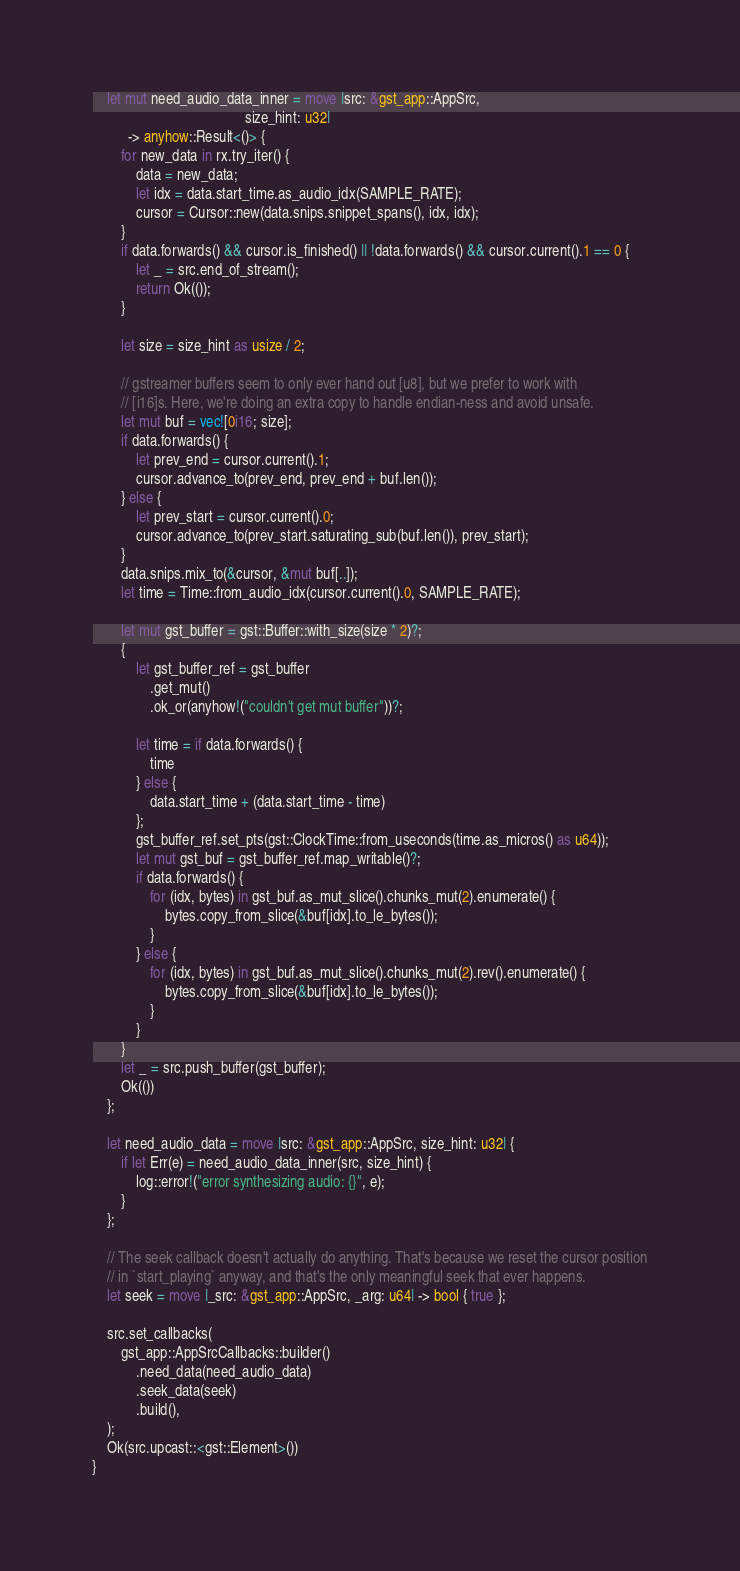<code> <loc_0><loc_0><loc_500><loc_500><_Rust_>    let mut need_audio_data_inner = move |src: &gst_app::AppSrc,
                                          size_hint: u32|
          -> anyhow::Result<()> {
        for new_data in rx.try_iter() {
            data = new_data;
            let idx = data.start_time.as_audio_idx(SAMPLE_RATE);
            cursor = Cursor::new(data.snips.snippet_spans(), idx, idx);
        }
        if data.forwards() && cursor.is_finished() || !data.forwards() && cursor.current().1 == 0 {
            let _ = src.end_of_stream();
            return Ok(());
        }

        let size = size_hint as usize / 2;

        // gstreamer buffers seem to only ever hand out [u8], but we prefer to work with
        // [i16]s. Here, we're doing an extra copy to handle endian-ness and avoid unsafe.
        let mut buf = vec![0i16; size];
        if data.forwards() {
            let prev_end = cursor.current().1;
            cursor.advance_to(prev_end, prev_end + buf.len());
        } else {
            let prev_start = cursor.current().0;
            cursor.advance_to(prev_start.saturating_sub(buf.len()), prev_start);
        }
        data.snips.mix_to(&cursor, &mut buf[..]);
        let time = Time::from_audio_idx(cursor.current().0, SAMPLE_RATE);

        let mut gst_buffer = gst::Buffer::with_size(size * 2)?;
        {
            let gst_buffer_ref = gst_buffer
                .get_mut()
                .ok_or(anyhow!("couldn't get mut buffer"))?;

            let time = if data.forwards() {
                time
            } else {
                data.start_time + (data.start_time - time)
            };
            gst_buffer_ref.set_pts(gst::ClockTime::from_useconds(time.as_micros() as u64));
            let mut gst_buf = gst_buffer_ref.map_writable()?;
            if data.forwards() {
                for (idx, bytes) in gst_buf.as_mut_slice().chunks_mut(2).enumerate() {
                    bytes.copy_from_slice(&buf[idx].to_le_bytes());
                }
            } else {
                for (idx, bytes) in gst_buf.as_mut_slice().chunks_mut(2).rev().enumerate() {
                    bytes.copy_from_slice(&buf[idx].to_le_bytes());
                }
            }
        }
        let _ = src.push_buffer(gst_buffer);
        Ok(())
    };

    let need_audio_data = move |src: &gst_app::AppSrc, size_hint: u32| {
        if let Err(e) = need_audio_data_inner(src, size_hint) {
            log::error!("error synthesizing audio: {}", e);
        }
    };

    // The seek callback doesn't actually do anything. That's because we reset the cursor position
    // in `start_playing` anyway, and that's the only meaningful seek that ever happens.
    let seek = move |_src: &gst_app::AppSrc, _arg: u64| -> bool { true };

    src.set_callbacks(
        gst_app::AppSrcCallbacks::builder()
            .need_data(need_audio_data)
            .seek_data(seek)
            .build(),
    );
    Ok(src.upcast::<gst::Element>())
}
</code> 